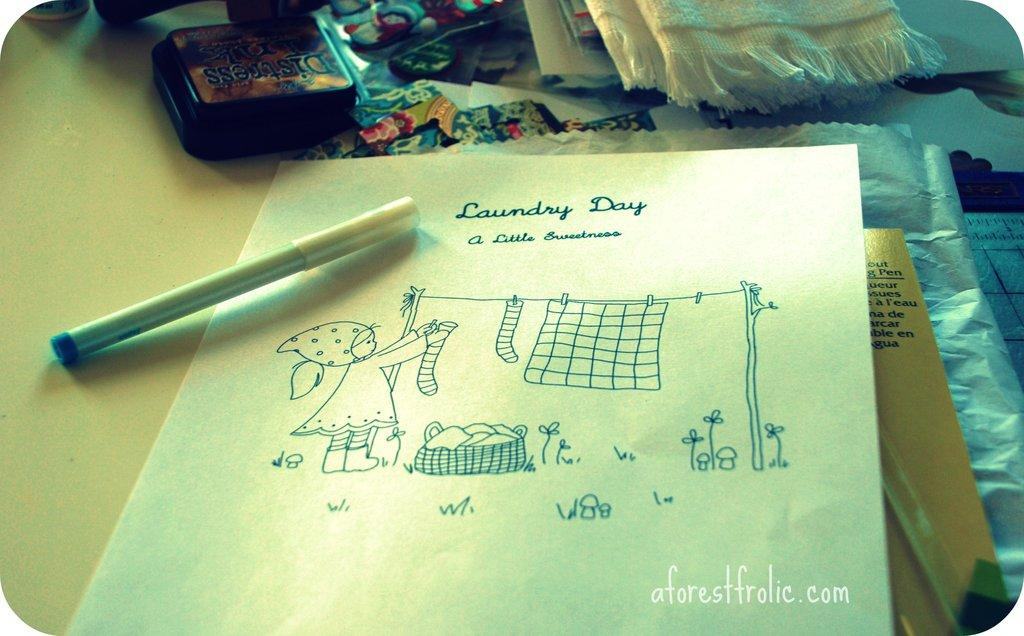What is on the table in the image? There is a pen, paper, a book, a cover, and cloth on the table. What else can be seen on the table? There are other objects on the table. Where is the text located in the image? The text is in the right bottom corner of the image. What type of brass instrument is being played by the judge in the image? There is no judge or brass instrument present in the image. How many planes are visible in the image? There are no planes visible in the image. 